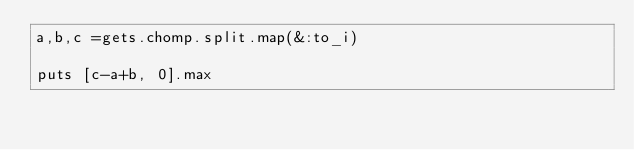Convert code to text. <code><loc_0><loc_0><loc_500><loc_500><_Ruby_>a,b,c =gets.chomp.split.map(&:to_i)

puts [c-a+b, 0].max
</code> 